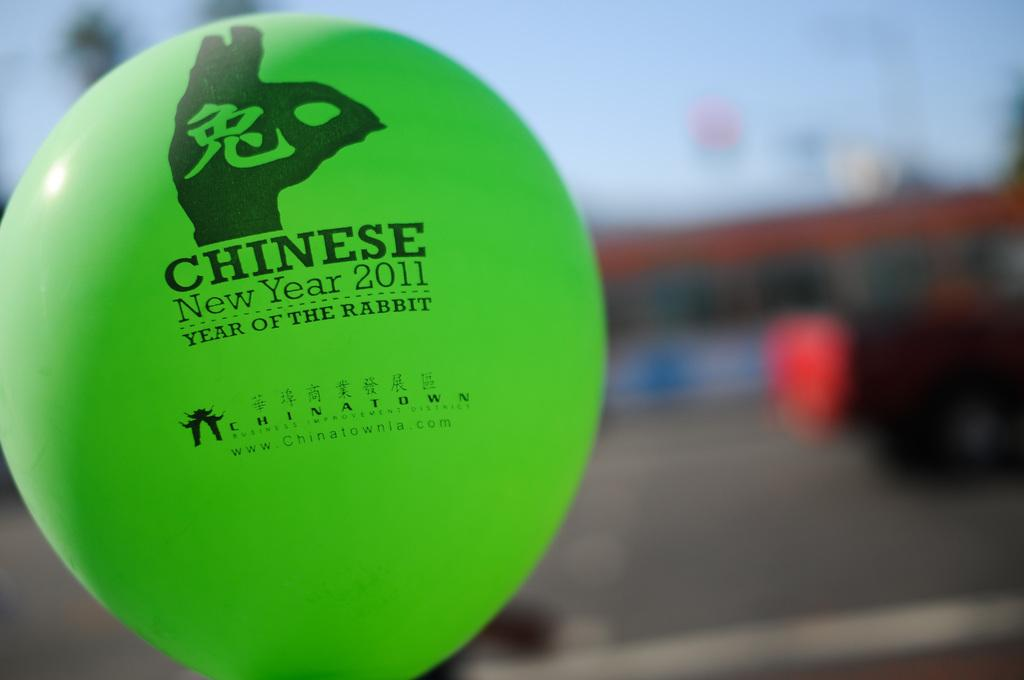What color is the ball in the image? The ball in the image is green. Can you describe the background of the image? The background of the image is blurred. What type of toys can be seen in the image? There are no toys present in the image; it only features a green color ball. What country is depicted in the image? The image does not depict any country; it only features a green color ball and a blurred background. 